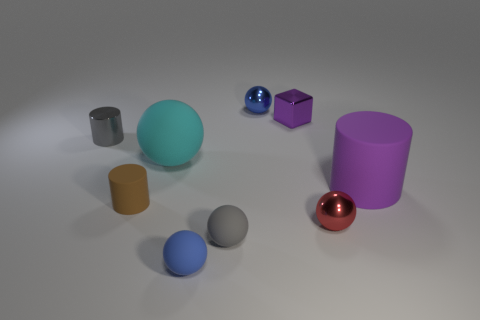Subtract all yellow balls. Subtract all brown cubes. How many balls are left? 5 Add 1 small gray shiny cylinders. How many objects exist? 10 Subtract all balls. How many objects are left? 4 Subtract 0 yellow balls. How many objects are left? 9 Subtract all tiny gray cylinders. Subtract all tiny rubber cylinders. How many objects are left? 7 Add 5 small matte cylinders. How many small matte cylinders are left? 6 Add 1 tiny gray objects. How many tiny gray objects exist? 3 